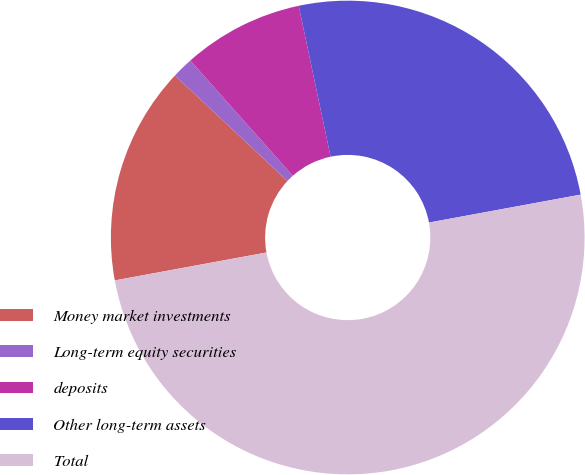Convert chart. <chart><loc_0><loc_0><loc_500><loc_500><pie_chart><fcel>Money market investments<fcel>Long-term equity securities<fcel>deposits<fcel>Other long-term assets<fcel>Total<nl><fcel>14.89%<fcel>1.44%<fcel>8.25%<fcel>25.42%<fcel>50.0%<nl></chart> 